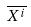<formula> <loc_0><loc_0><loc_500><loc_500>\overline { X ^ { i } }</formula> 